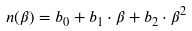Convert formula to latex. <formula><loc_0><loc_0><loc_500><loc_500>n ( \beta ) = b _ { 0 } + b _ { 1 } \cdot \beta + b _ { 2 } \cdot \beta ^ { 2 }</formula> 